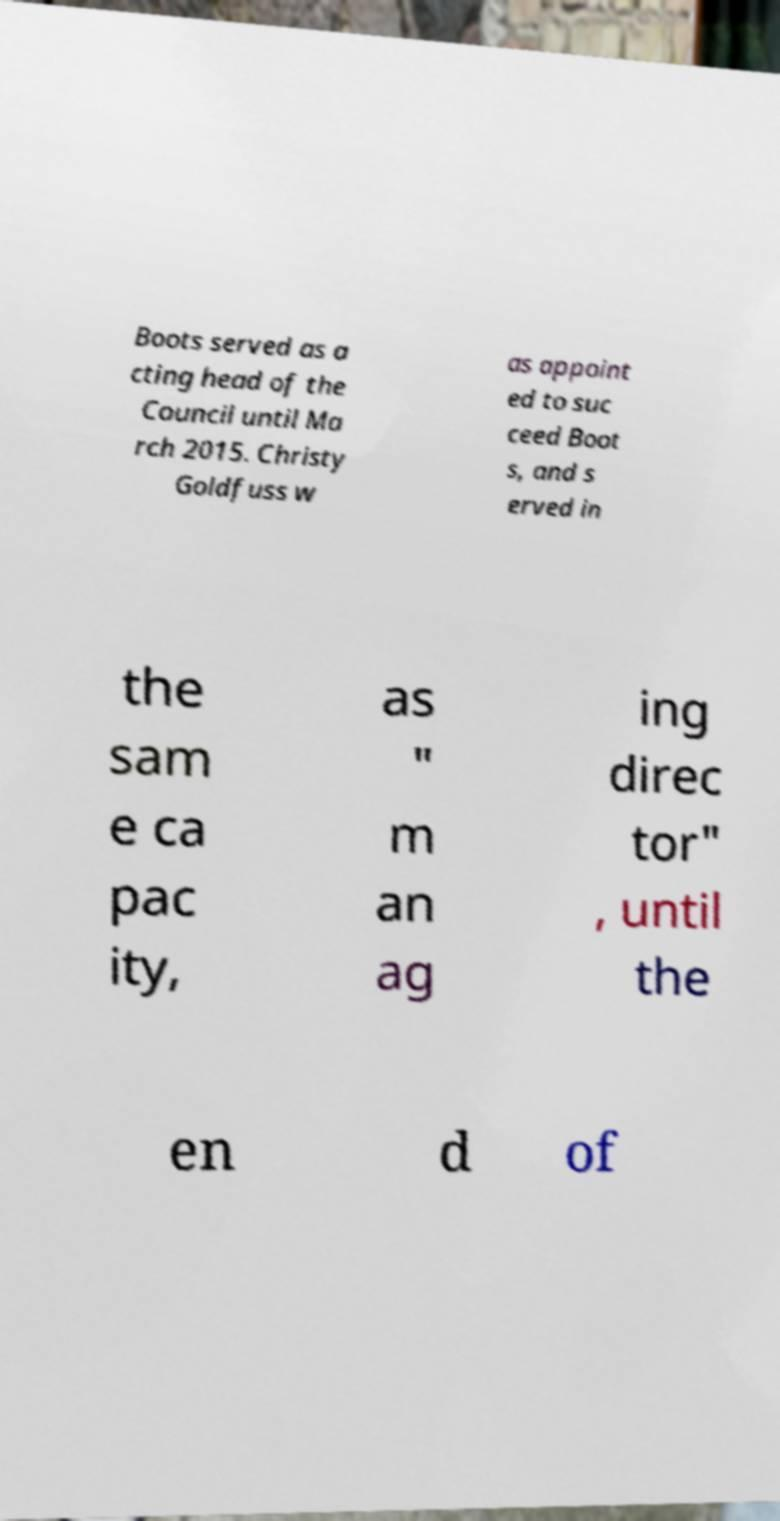Could you assist in decoding the text presented in this image and type it out clearly? Boots served as a cting head of the Council until Ma rch 2015. Christy Goldfuss w as appoint ed to suc ceed Boot s, and s erved in the sam e ca pac ity, as " m an ag ing direc tor" , until the en d of 